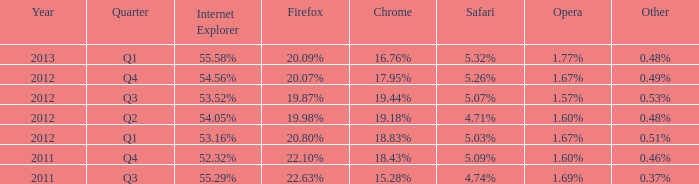What period has 53.52% as the internet explorer? 2012 Q3. 